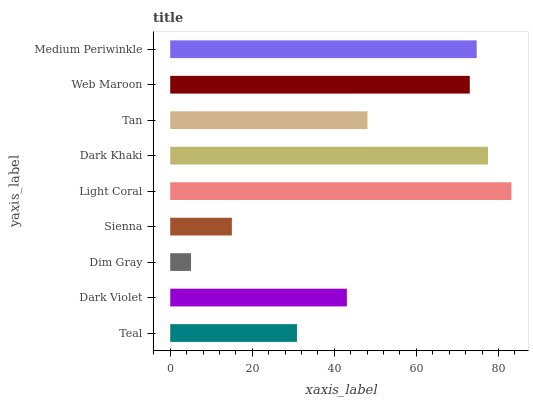Is Dim Gray the minimum?
Answer yes or no. Yes. Is Light Coral the maximum?
Answer yes or no. Yes. Is Dark Violet the minimum?
Answer yes or no. No. Is Dark Violet the maximum?
Answer yes or no. No. Is Dark Violet greater than Teal?
Answer yes or no. Yes. Is Teal less than Dark Violet?
Answer yes or no. Yes. Is Teal greater than Dark Violet?
Answer yes or no. No. Is Dark Violet less than Teal?
Answer yes or no. No. Is Tan the high median?
Answer yes or no. Yes. Is Tan the low median?
Answer yes or no. Yes. Is Dim Gray the high median?
Answer yes or no. No. Is Dim Gray the low median?
Answer yes or no. No. 